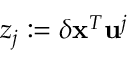<formula> <loc_0><loc_0><loc_500><loc_500>z _ { j } \colon = \delta x ^ { T } u ^ { j }</formula> 